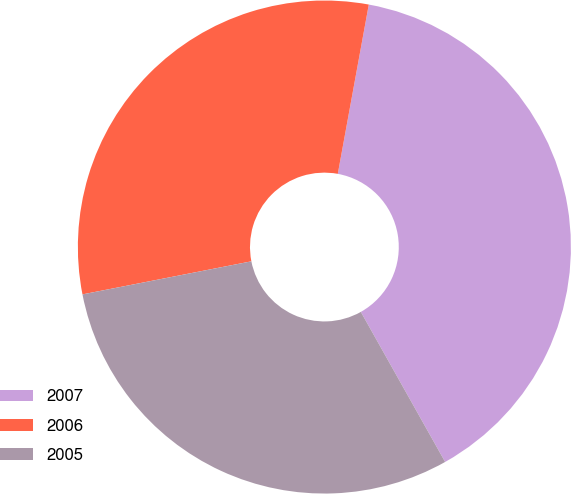Convert chart to OTSL. <chart><loc_0><loc_0><loc_500><loc_500><pie_chart><fcel>2007<fcel>2006<fcel>2005<nl><fcel>38.97%<fcel>30.96%<fcel>30.07%<nl></chart> 